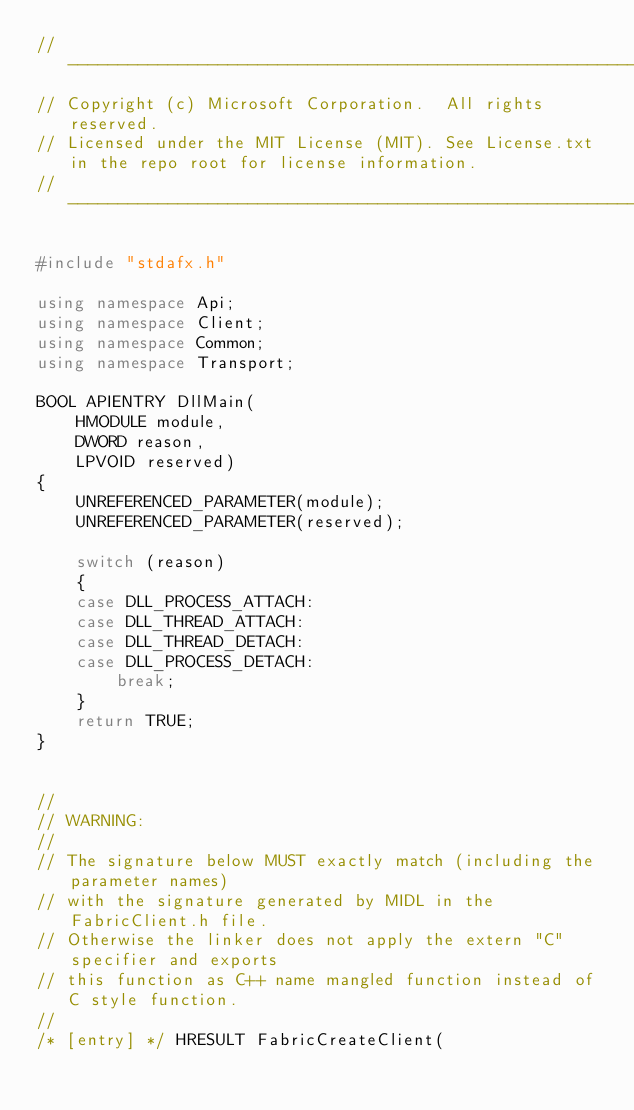<code> <loc_0><loc_0><loc_500><loc_500><_C++_>// ------------------------------------------------------------
// Copyright (c) Microsoft Corporation.  All rights reserved.
// Licensed under the MIT License (MIT). See License.txt in the repo root for license information.
// ------------------------------------------------------------

#include "stdafx.h"

using namespace Api;
using namespace Client;
using namespace Common;
using namespace Transport;

BOOL APIENTRY DllMain(
    HMODULE module,
    DWORD reason,
    LPVOID reserved)
{
    UNREFERENCED_PARAMETER(module);
    UNREFERENCED_PARAMETER(reserved);

    switch (reason)
    {
    case DLL_PROCESS_ATTACH:
    case DLL_THREAD_ATTACH:
    case DLL_THREAD_DETACH:
    case DLL_PROCESS_DETACH:
        break;
    }
    return TRUE;
}


//
// WARNING: 
//
// The signature below MUST exactly match (including the parameter names)
// with the signature generated by MIDL in the FabricClient.h file. 
// Otherwise the linker does not apply the extern "C" specifier and exports 
// this function as C++ name mangled function instead of C style function.
// 
/* [entry] */ HRESULT FabricCreateClient( </code> 